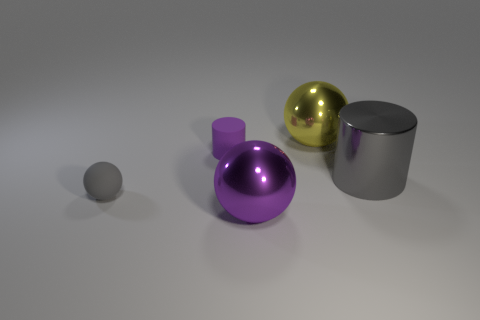Subtract all small spheres. How many spheres are left? 2 Subtract 1 spheres. How many spheres are left? 2 Add 3 small gray matte objects. How many objects exist? 8 Subtract all cylinders. How many objects are left? 3 Add 5 purple matte cylinders. How many purple matte cylinders are left? 6 Add 4 small purple cylinders. How many small purple cylinders exist? 5 Subtract 0 brown cylinders. How many objects are left? 5 Subtract all matte spheres. Subtract all big gray cylinders. How many objects are left? 3 